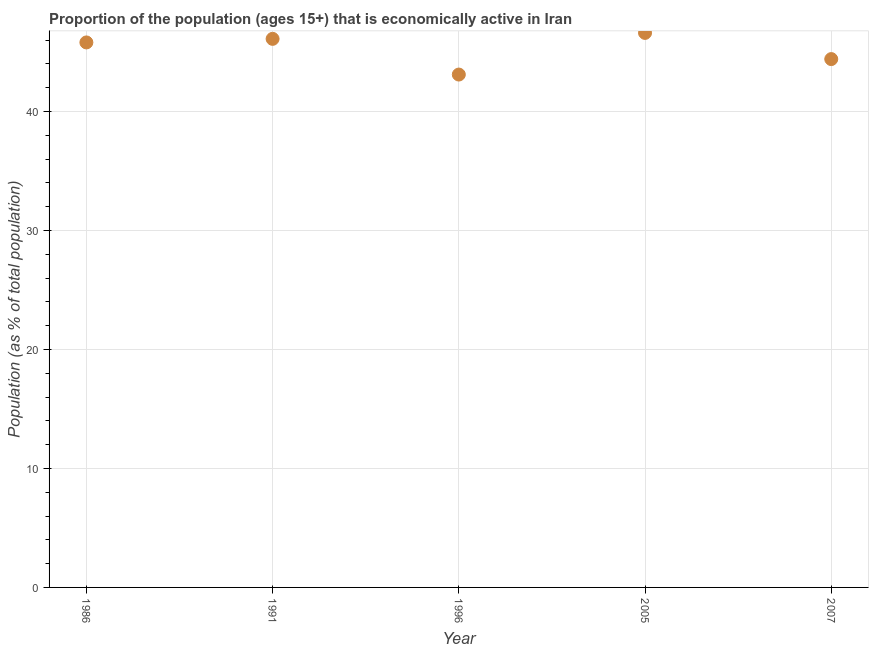What is the percentage of economically active population in 1991?
Give a very brief answer. 46.1. Across all years, what is the maximum percentage of economically active population?
Ensure brevity in your answer.  46.6. Across all years, what is the minimum percentage of economically active population?
Provide a short and direct response. 43.1. In which year was the percentage of economically active population maximum?
Provide a short and direct response. 2005. What is the sum of the percentage of economically active population?
Give a very brief answer. 226. What is the difference between the percentage of economically active population in 1991 and 2007?
Offer a very short reply. 1.7. What is the average percentage of economically active population per year?
Give a very brief answer. 45.2. What is the median percentage of economically active population?
Offer a very short reply. 45.8. What is the ratio of the percentage of economically active population in 1991 to that in 1996?
Keep it short and to the point. 1.07. Is the percentage of economically active population in 1991 less than that in 2005?
Your answer should be compact. Yes. Is the difference between the percentage of economically active population in 1991 and 2007 greater than the difference between any two years?
Ensure brevity in your answer.  No. What is the difference between the highest and the lowest percentage of economically active population?
Ensure brevity in your answer.  3.5. In how many years, is the percentage of economically active population greater than the average percentage of economically active population taken over all years?
Keep it short and to the point. 3. Does the percentage of economically active population monotonically increase over the years?
Make the answer very short. No. How many years are there in the graph?
Keep it short and to the point. 5. What is the title of the graph?
Your answer should be compact. Proportion of the population (ages 15+) that is economically active in Iran. What is the label or title of the Y-axis?
Offer a very short reply. Population (as % of total population). What is the Population (as % of total population) in 1986?
Ensure brevity in your answer.  45.8. What is the Population (as % of total population) in 1991?
Give a very brief answer. 46.1. What is the Population (as % of total population) in 1996?
Your answer should be compact. 43.1. What is the Population (as % of total population) in 2005?
Make the answer very short. 46.6. What is the Population (as % of total population) in 2007?
Your answer should be compact. 44.4. What is the difference between the Population (as % of total population) in 1986 and 1991?
Ensure brevity in your answer.  -0.3. What is the difference between the Population (as % of total population) in 1986 and 1996?
Provide a short and direct response. 2.7. What is the difference between the Population (as % of total population) in 1986 and 2005?
Make the answer very short. -0.8. What is the difference between the Population (as % of total population) in 2005 and 2007?
Give a very brief answer. 2.2. What is the ratio of the Population (as % of total population) in 1986 to that in 1996?
Ensure brevity in your answer.  1.06. What is the ratio of the Population (as % of total population) in 1986 to that in 2007?
Keep it short and to the point. 1.03. What is the ratio of the Population (as % of total population) in 1991 to that in 1996?
Your answer should be very brief. 1.07. What is the ratio of the Population (as % of total population) in 1991 to that in 2007?
Your answer should be very brief. 1.04. What is the ratio of the Population (as % of total population) in 1996 to that in 2005?
Provide a short and direct response. 0.93. What is the ratio of the Population (as % of total population) in 1996 to that in 2007?
Your answer should be very brief. 0.97. What is the ratio of the Population (as % of total population) in 2005 to that in 2007?
Provide a succinct answer. 1.05. 